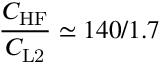<formula> <loc_0><loc_0><loc_500><loc_500>\frac { C _ { H F } } { C _ { L 2 } } \simeq 1 4 0 / 1 . 7</formula> 